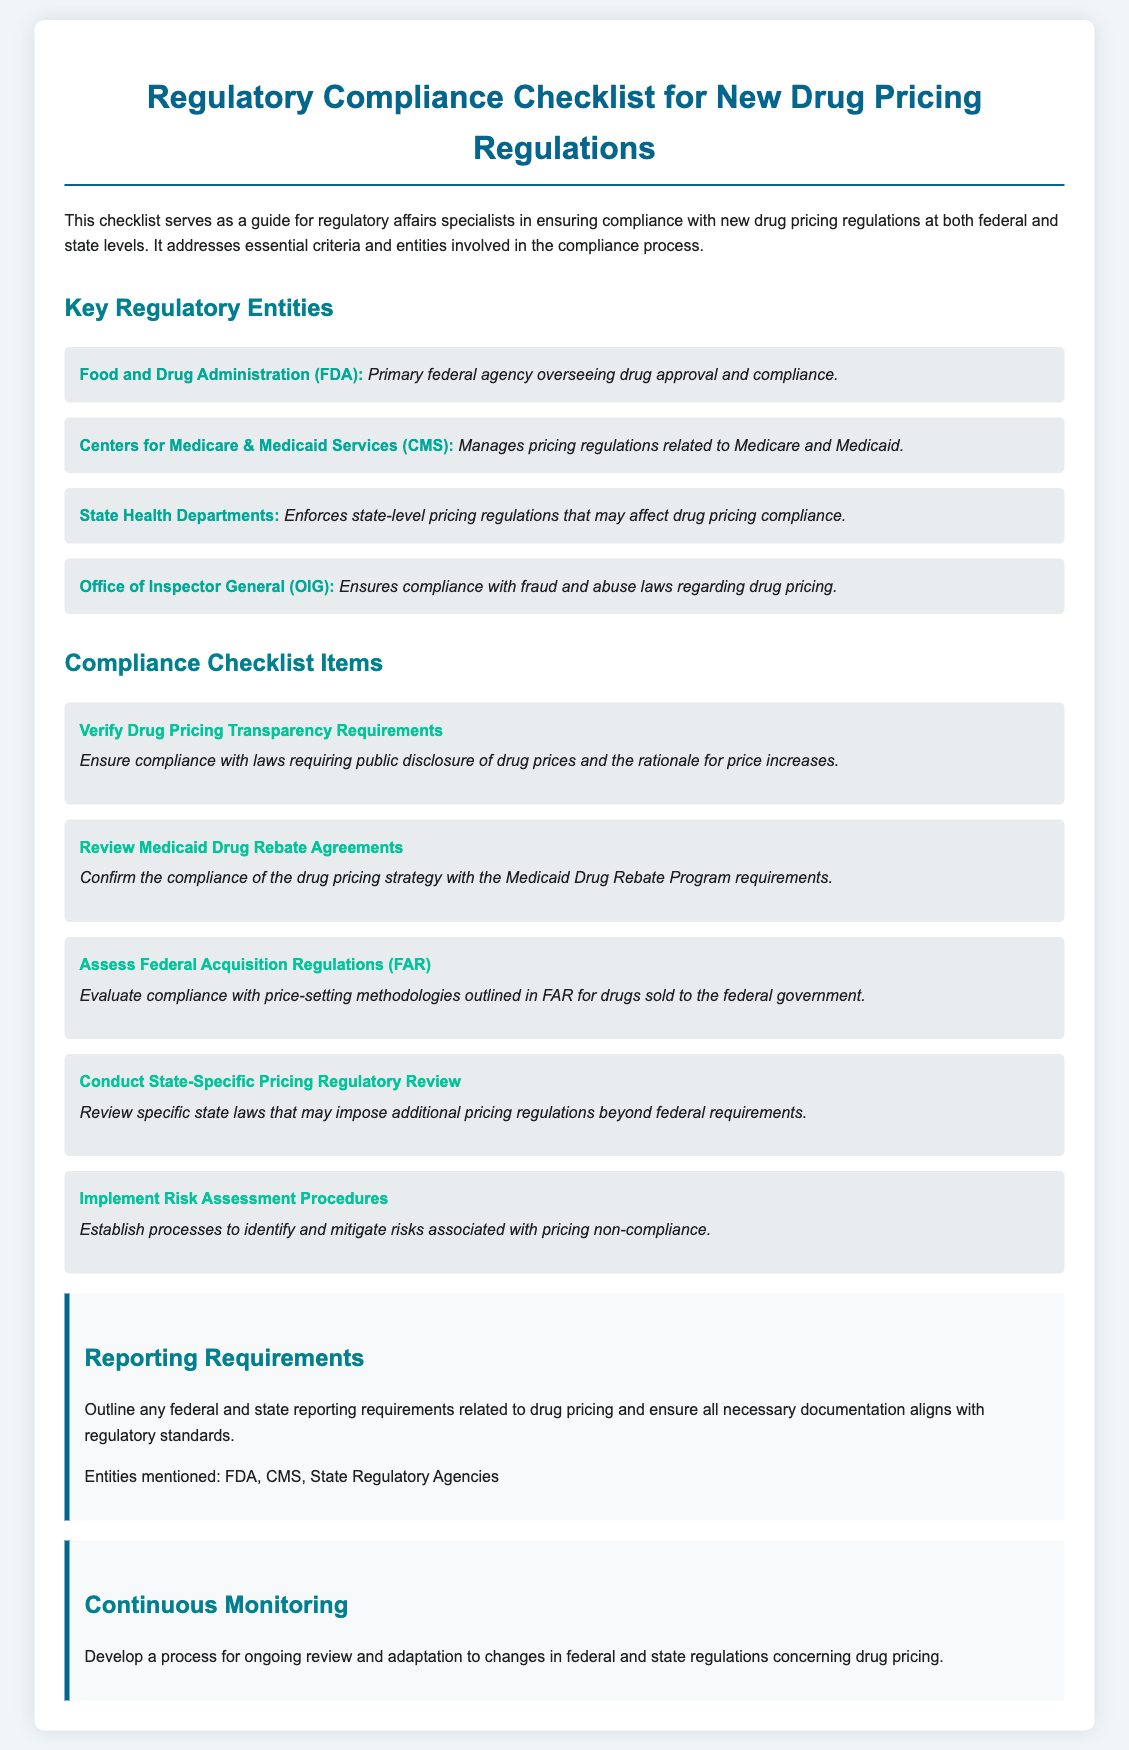What is the primary federal agency overseeing drug approval? The document states that the FDA is the primary federal agency overseeing drug approval and compliance.
Answer: FDA What manages pricing regulations related to Medicare and Medicaid? According to the document, the Centers for Medicare & Medicaid Services is responsible for managing pricing regulations related to Medicare and Medicaid.
Answer: Centers for Medicare & Medicaid Services How many items are listed in the Compliance Checklist? The document enumerates five specific items in the Compliance Checklist section.
Answer: 5 What do the risk assessment procedures aim to establish? The document explains that the risk assessment procedures aim to identify and mitigate risks associated with pricing non-compliance.
Answer: Processes to identify and mitigate risks What should be ensured regarding federal and state reporting requirements? The document indicates that all necessary documentation must align with regulatory standards related to drug pricing.
Answer: Align with regulatory standards What is the purpose of the Continuous Monitoring section? The document describes that continuous monitoring is intended for ongoing review and adaptation to changes in federal and state regulations concerning drug pricing.
Answer: Ongoing review and adaptation 